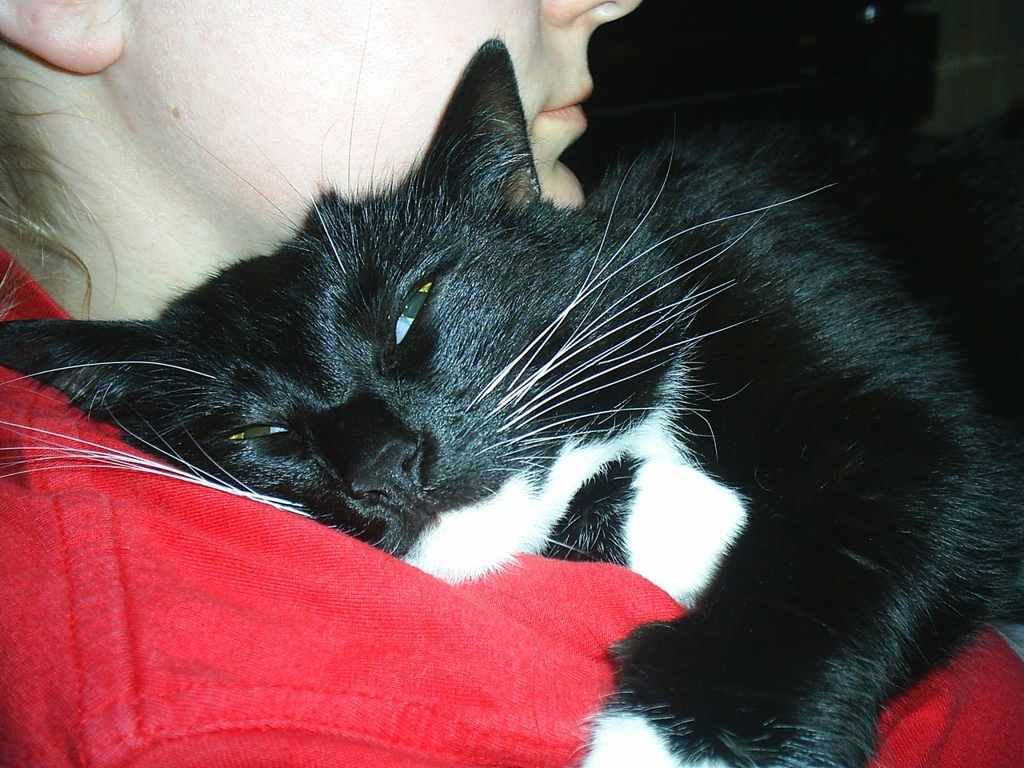Is the image clear?
A. Yes
B. No
Answer with the option's letter from the given choices directly.
 A. 